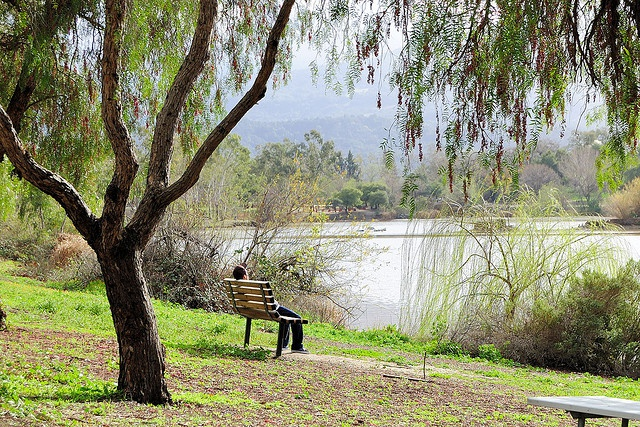Describe the objects in this image and their specific colors. I can see bench in olive, black, maroon, and white tones and people in olive, black, lightgray, gray, and darkgray tones in this image. 